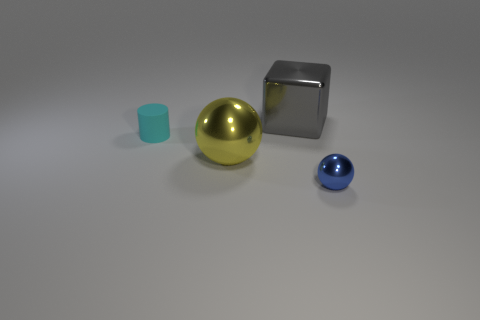Add 4 gray objects. How many objects exist? 8 Subtract all cylinders. How many objects are left? 3 Add 1 purple shiny balls. How many purple shiny balls exist? 1 Subtract 0 brown spheres. How many objects are left? 4 Subtract all small gray rubber objects. Subtract all cyan things. How many objects are left? 3 Add 3 large yellow shiny balls. How many large yellow shiny balls are left? 4 